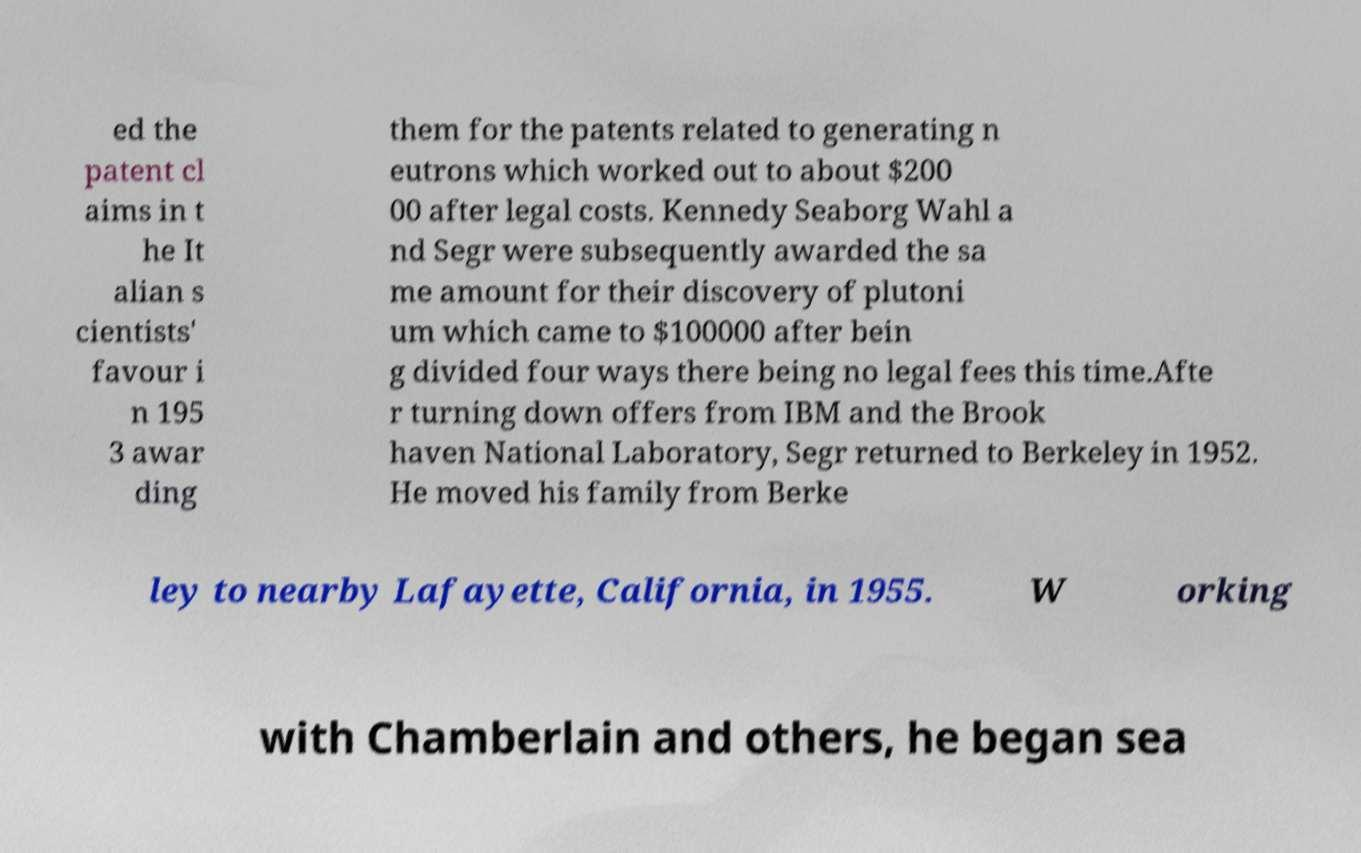Could you assist in decoding the text presented in this image and type it out clearly? ed the patent cl aims in t he It alian s cientists' favour i n 195 3 awar ding them for the patents related to generating n eutrons which worked out to about $200 00 after legal costs. Kennedy Seaborg Wahl a nd Segr were subsequently awarded the sa me amount for their discovery of plutoni um which came to $100000 after bein g divided four ways there being no legal fees this time.Afte r turning down offers from IBM and the Brook haven National Laboratory, Segr returned to Berkeley in 1952. He moved his family from Berke ley to nearby Lafayette, California, in 1955. W orking with Chamberlain and others, he began sea 